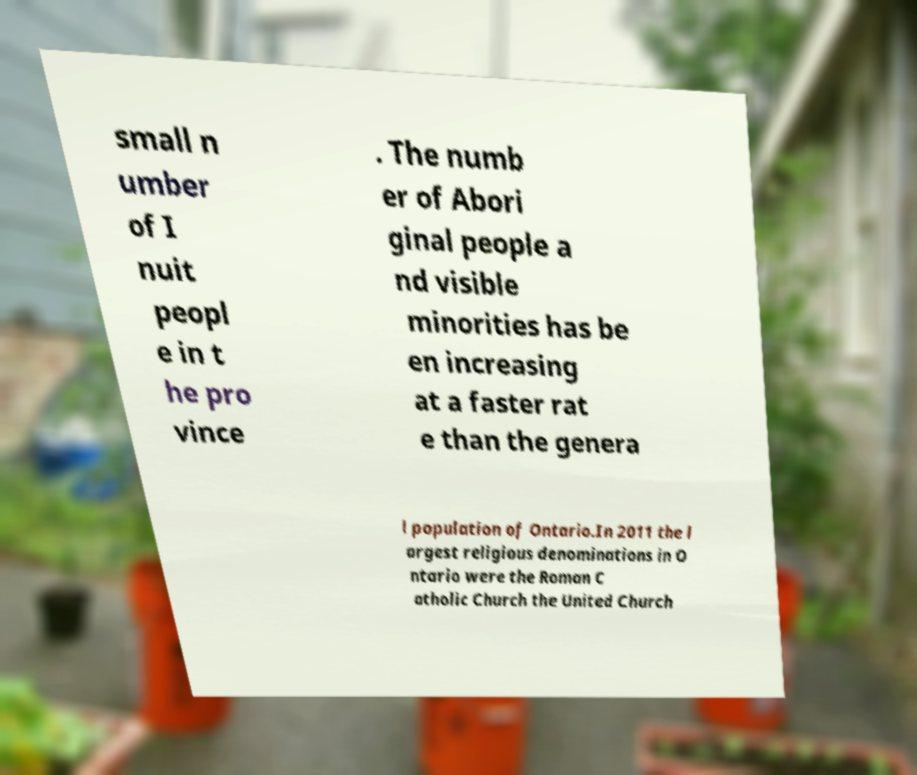What messages or text are displayed in this image? I need them in a readable, typed format. small n umber of I nuit peopl e in t he pro vince . The numb er of Abori ginal people a nd visible minorities has be en increasing at a faster rat e than the genera l population of Ontario.In 2011 the l argest religious denominations in O ntario were the Roman C atholic Church the United Church 